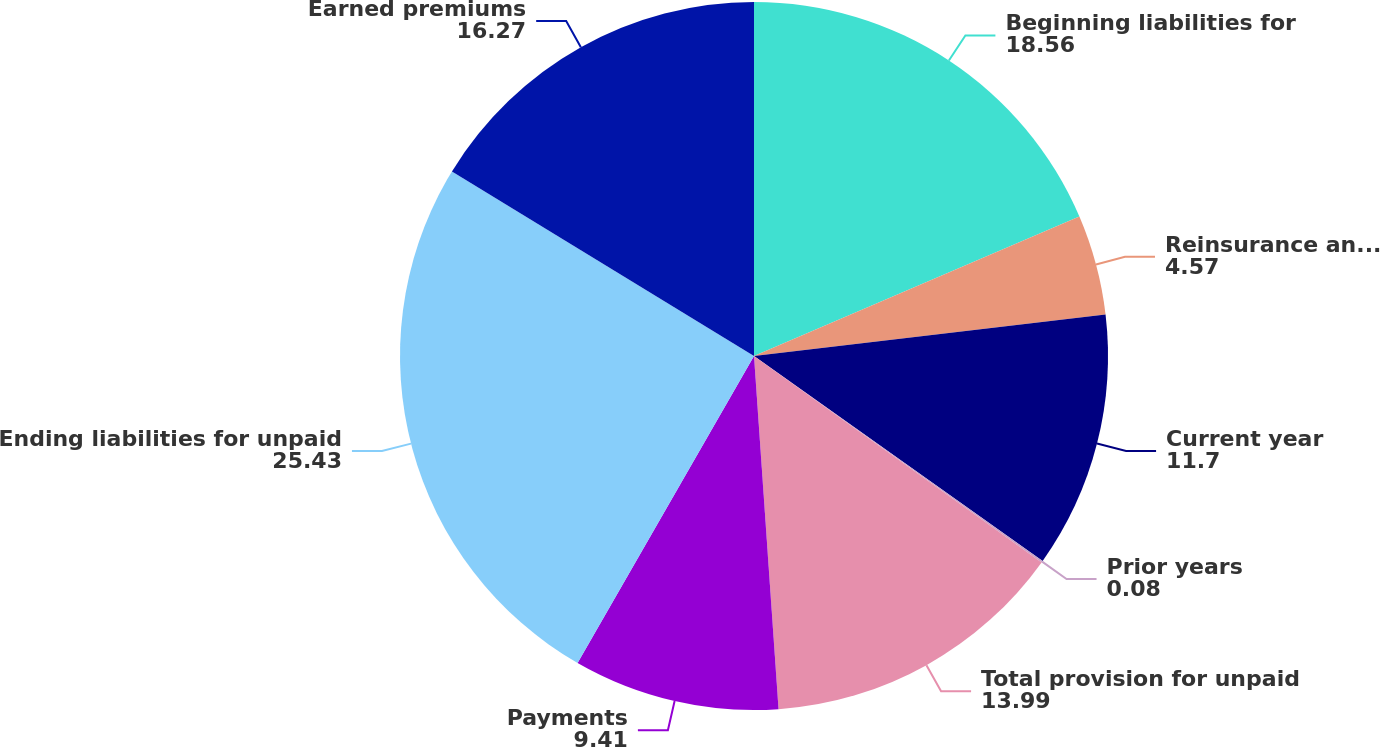Convert chart. <chart><loc_0><loc_0><loc_500><loc_500><pie_chart><fcel>Beginning liabilities for<fcel>Reinsurance and other<fcel>Current year<fcel>Prior years<fcel>Total provision for unpaid<fcel>Payments<fcel>Ending liabilities for unpaid<fcel>Earned premiums<nl><fcel>18.56%<fcel>4.57%<fcel>11.7%<fcel>0.08%<fcel>13.99%<fcel>9.41%<fcel>25.43%<fcel>16.27%<nl></chart> 